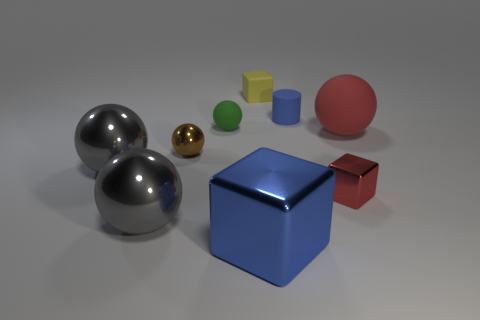Subtract all gray cubes. How many gray balls are left? 2 Subtract all green spheres. How many spheres are left? 4 Subtract all shiny blocks. How many blocks are left? 1 Subtract all brown blocks. Subtract all yellow spheres. How many blocks are left? 3 Add 1 big metal cubes. How many objects exist? 10 Add 4 gray metal spheres. How many gray metal spheres exist? 6 Subtract 0 green blocks. How many objects are left? 9 Subtract all cubes. How many objects are left? 6 Subtract all big cyan rubber cubes. Subtract all big matte objects. How many objects are left? 8 Add 4 large red rubber balls. How many large red rubber balls are left? 5 